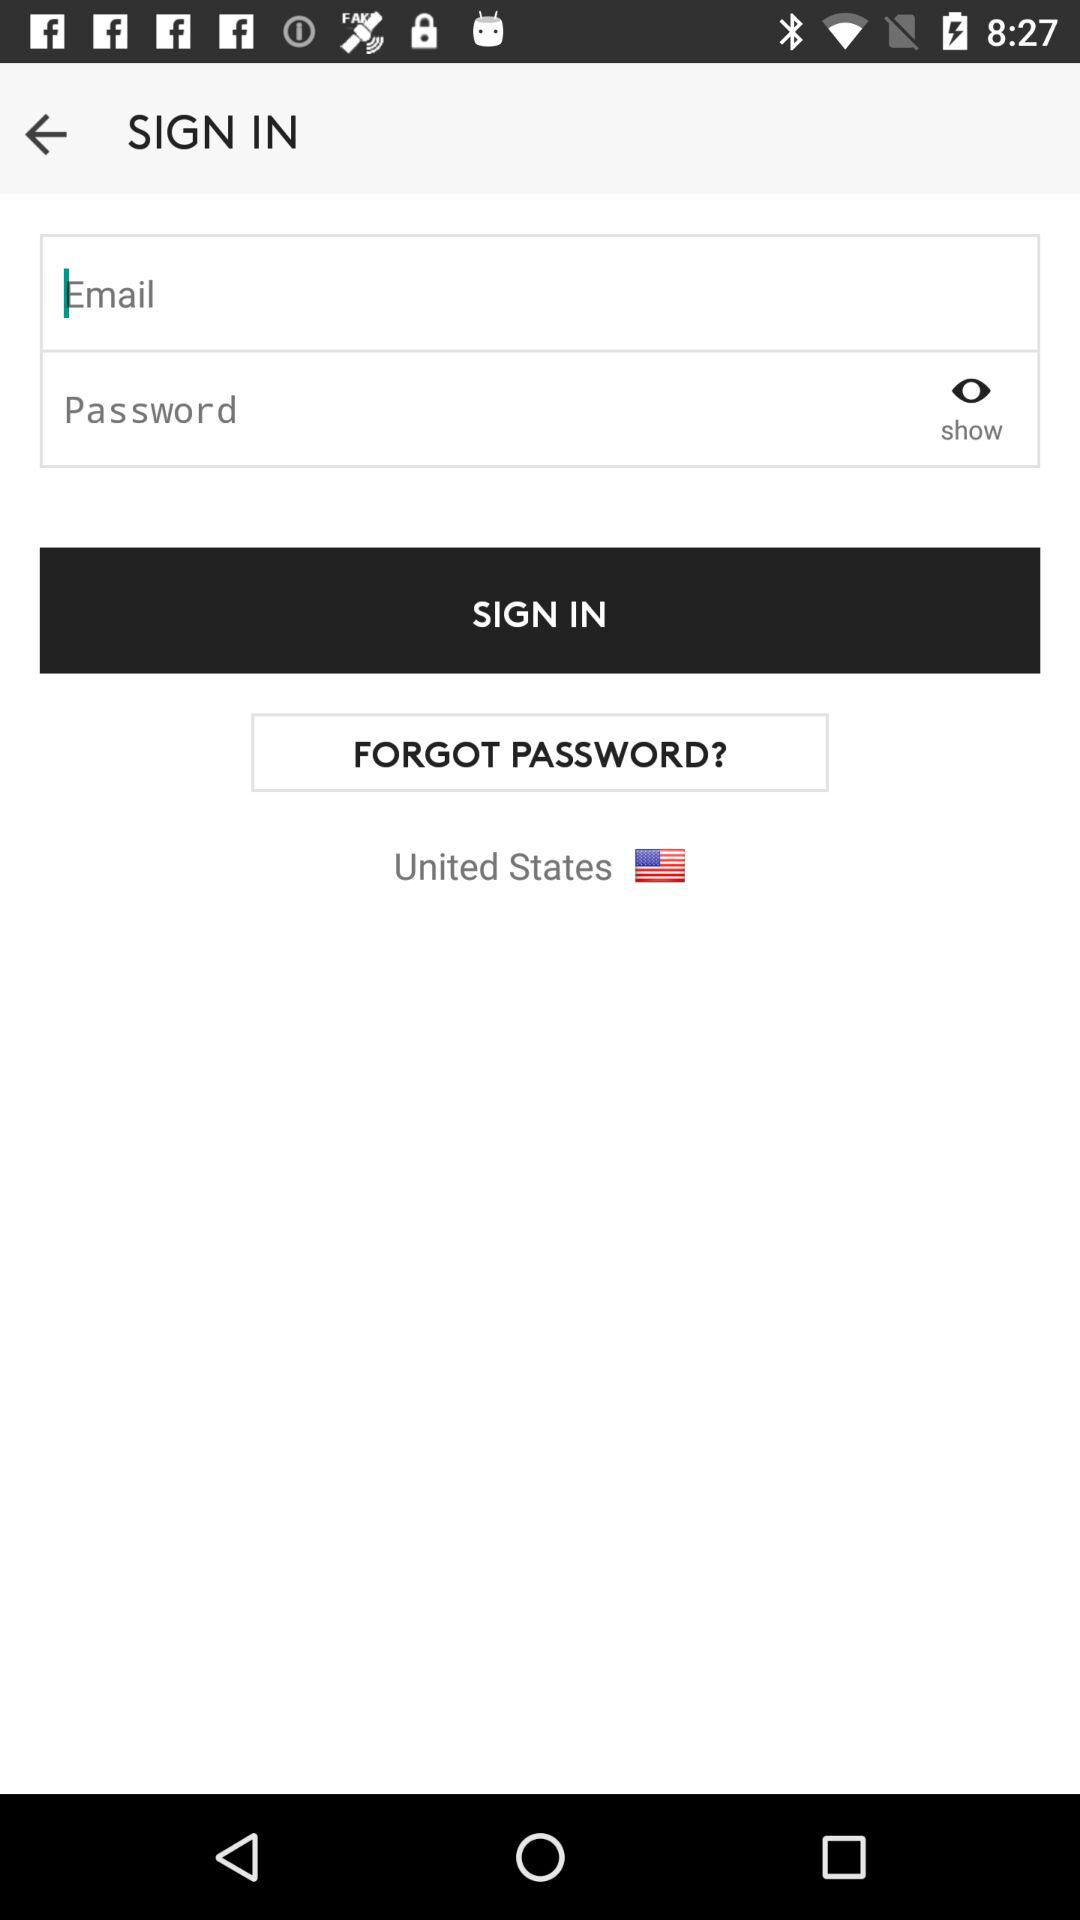How many text inputs are in the sign in form?
Answer the question using a single word or phrase. 2 